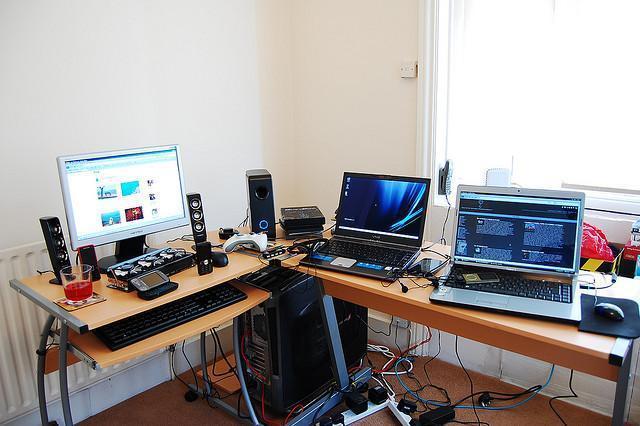How many laptops are there?
Give a very brief answer. 2. How many elephants are there?
Give a very brief answer. 0. 